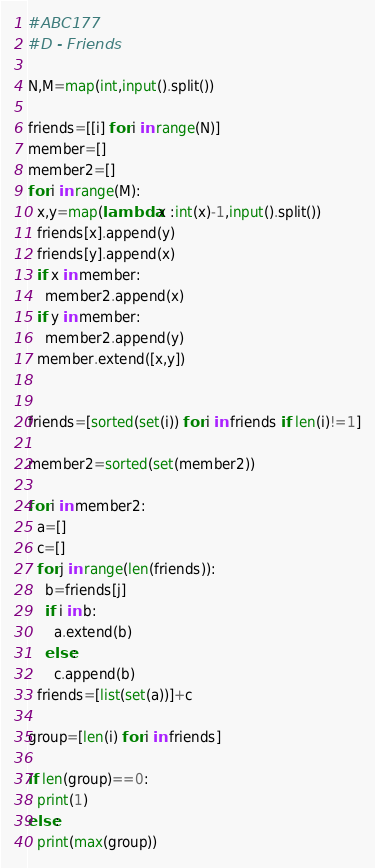Convert code to text. <code><loc_0><loc_0><loc_500><loc_500><_Python_>#ABC177
#D - Friends

N,M=map(int,input().split())

friends=[[i] for i in range(N)]
member=[]
member2=[]
for i in range(M):
  x,y=map(lambda x :int(x)-1,input().split())
  friends[x].append(y)
  friends[y].append(x)
  if x in member:
    member2.append(x)
  if y in member:
    member2.append(y)
  member.extend([x,y])


friends=[sorted(set(i)) for i in friends if len(i)!=1]

member2=sorted(set(member2))

for i in member2:
  a=[]
  c=[]
  for j in range(len(friends)):
    b=friends[j]
    if i in b:
      a.extend(b)
    else:
      c.append(b)
  friends=[list(set(a))]+c
  
group=[len(i) for i in friends]    

if len(group)==0:
  print(1)
else:
  print(max(group))</code> 